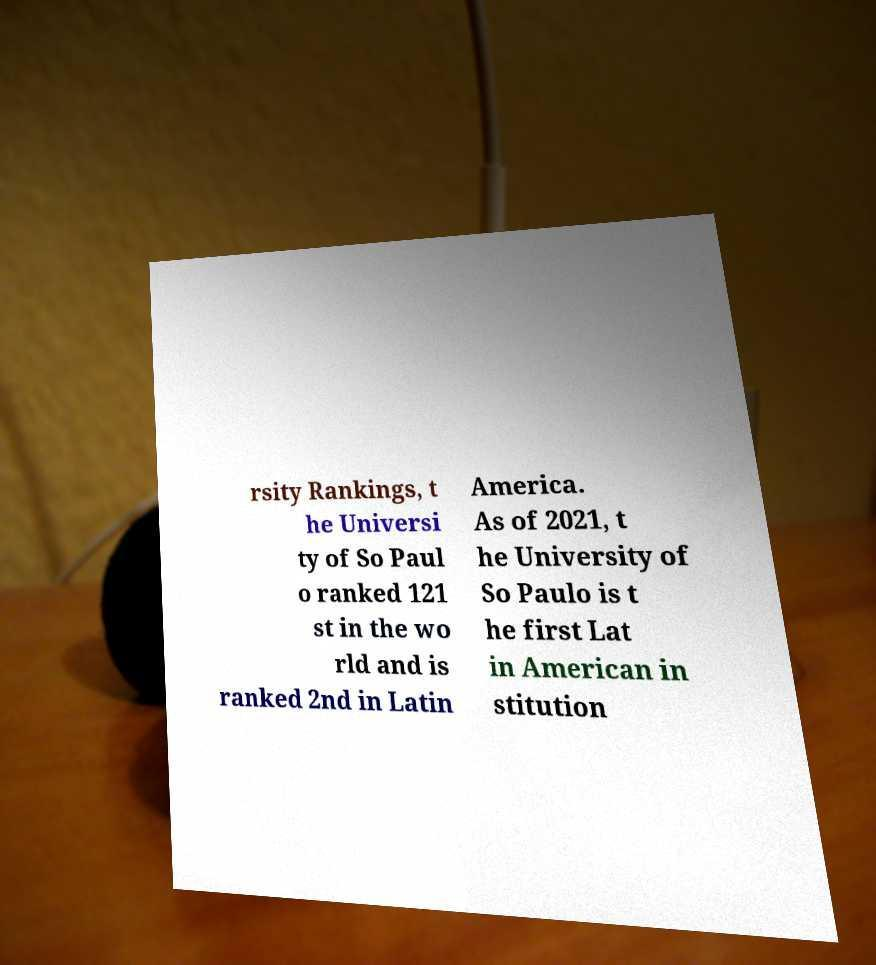What messages or text are displayed in this image? I need them in a readable, typed format. rsity Rankings, t he Universi ty of So Paul o ranked 121 st in the wo rld and is ranked 2nd in Latin America. As of 2021, t he University of So Paulo is t he first Lat in American in stitution 